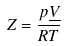<formula> <loc_0><loc_0><loc_500><loc_500>Z = \frac { p \underline { V } } { R T }</formula> 